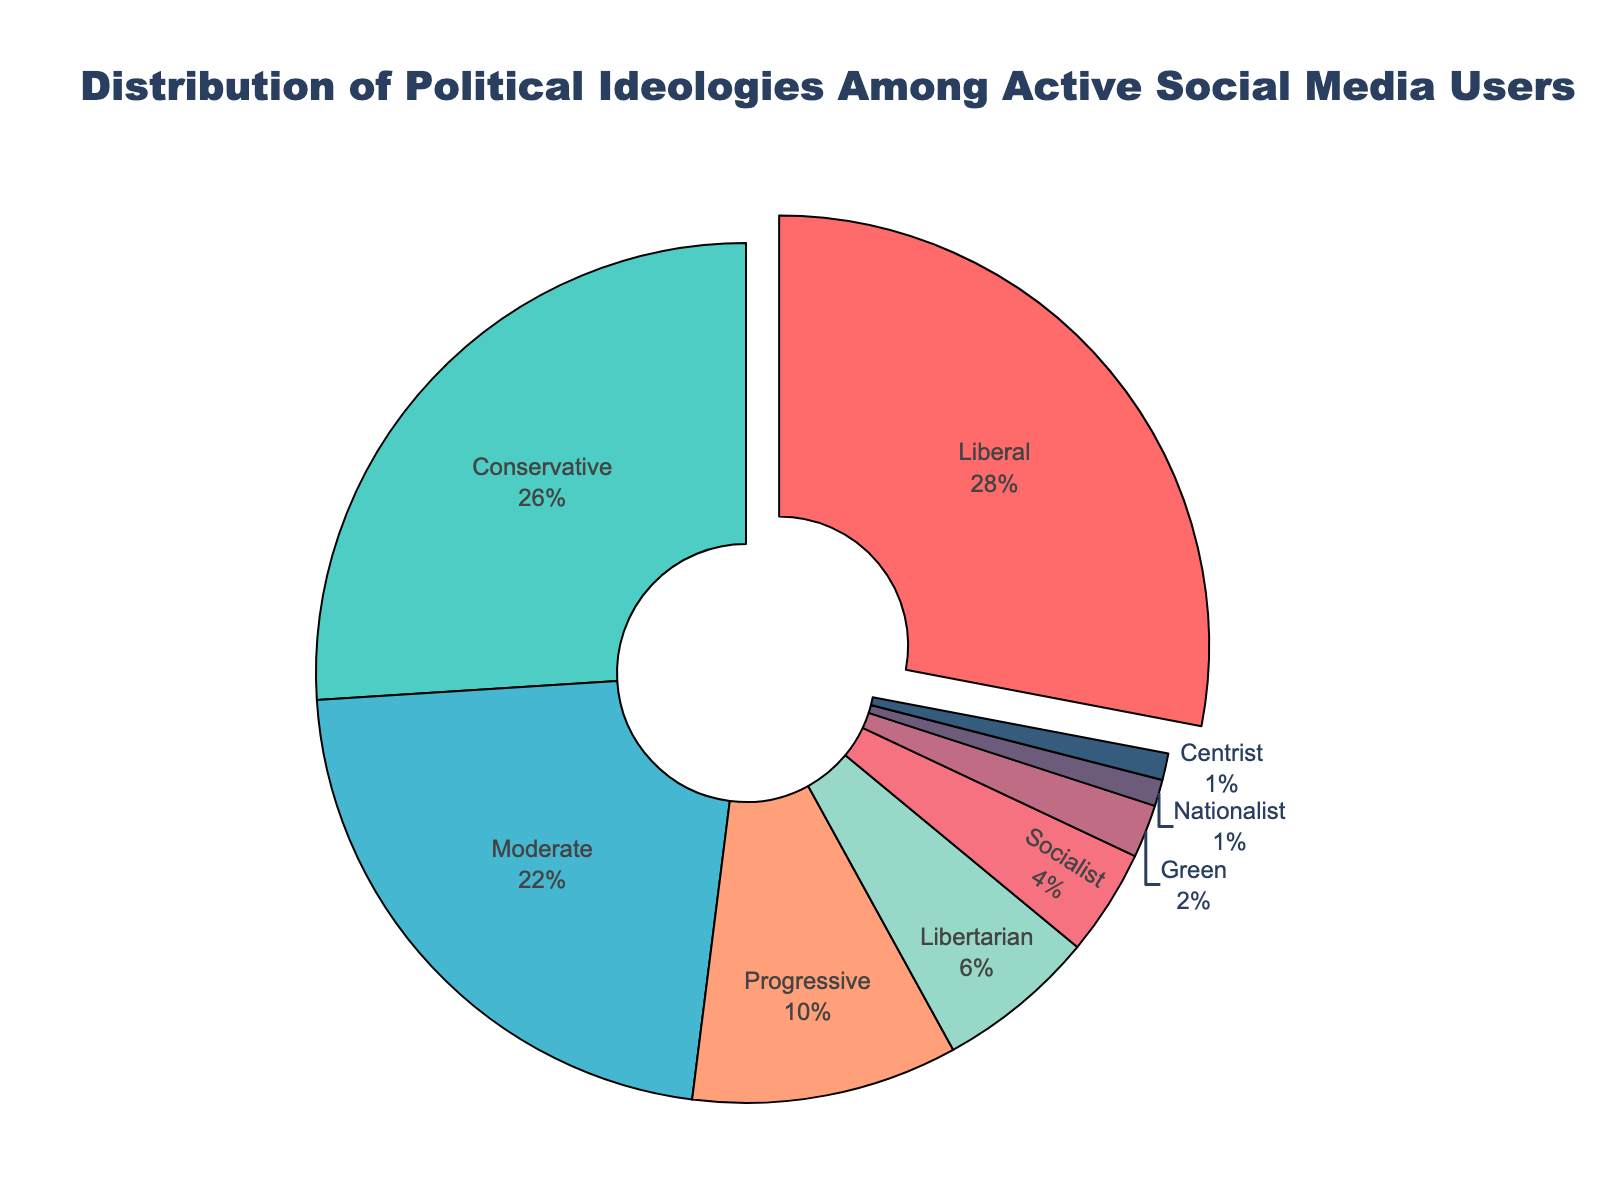What's the most common political ideology among active social media users? The most common ideology is represented by the largest segment in the pie chart. By observing the size and the percentage shown, the segment corresponding to Liberal is the largest at 28%.
Answer: Liberal Which political ideology is slightly less common than Liberal but more common than Moderate? The political ideology immediately less common than Liberal (28%) and more common than Moderate (22%) is indicated by the second largest segment. This segment is Conservative at 26%.
Answer: Conservative How much larger is the percentage of Progressives compared to the percentage of Libertarians? To determine this, subtract the percentage of Libertarians (6%) from the percentage of Progressives (10%). The difference is 10% - 6% = 4%.
Answer: 4% What is the combined percentage of Socialist and Green ideologies among active social media users? Add the percentages of Socialists (4%) and Greens (2%). The combined percentage is 4% + 2% = 6%.
Answer: 6% Which political ideologies have the same percentage representation in the pie chart? Look for segments with equal percentage values. Nationalist and Centrist both have the same percentage representation of 1%.
Answer: Nationalist, Centrist What percentage range includes Moderate, Progressive, and Libertarian ideologies? Identify the percentages for these ideologies: Moderates (22%), Progressives (10%), Libertarians (6%). The range spans from 6% to 22%.
Answer: 6% to 22% Are there more active social media users identifying with Progressive or Libertarian ideologies? Observe the respective segments in the pie chart. The segment for Progressives (10%) is larger than for Libertarians (6%).
Answer: Progressive What is the difference in percentage between the least and most common political ideologies among active social media users? Subtract the percentage of the least common ideology (Nationalist and Centrist, each 1%) from the most common ideology (Liberal, 28%). The difference is 28% - 1% = 27%.
Answer: 27% What percentage of active social media users identify with ideologies categorized as less than 5% each? Identify ideologies with percentages less than 5%: Socialist (4%), Green (2%), Nationalist (1%), Centrist (1%). Sum these percentages: 4% + 2% + 1% + 1% = 8%.
Answer: 8% How do the percentages of Liberal and Conservative ideologies compare? Liberals represent 28%, and Conservatives represent 26%. By comparing these values, Liberals have a higher percentage by 2%.
Answer: Liberals have a higher percentage by 2% 